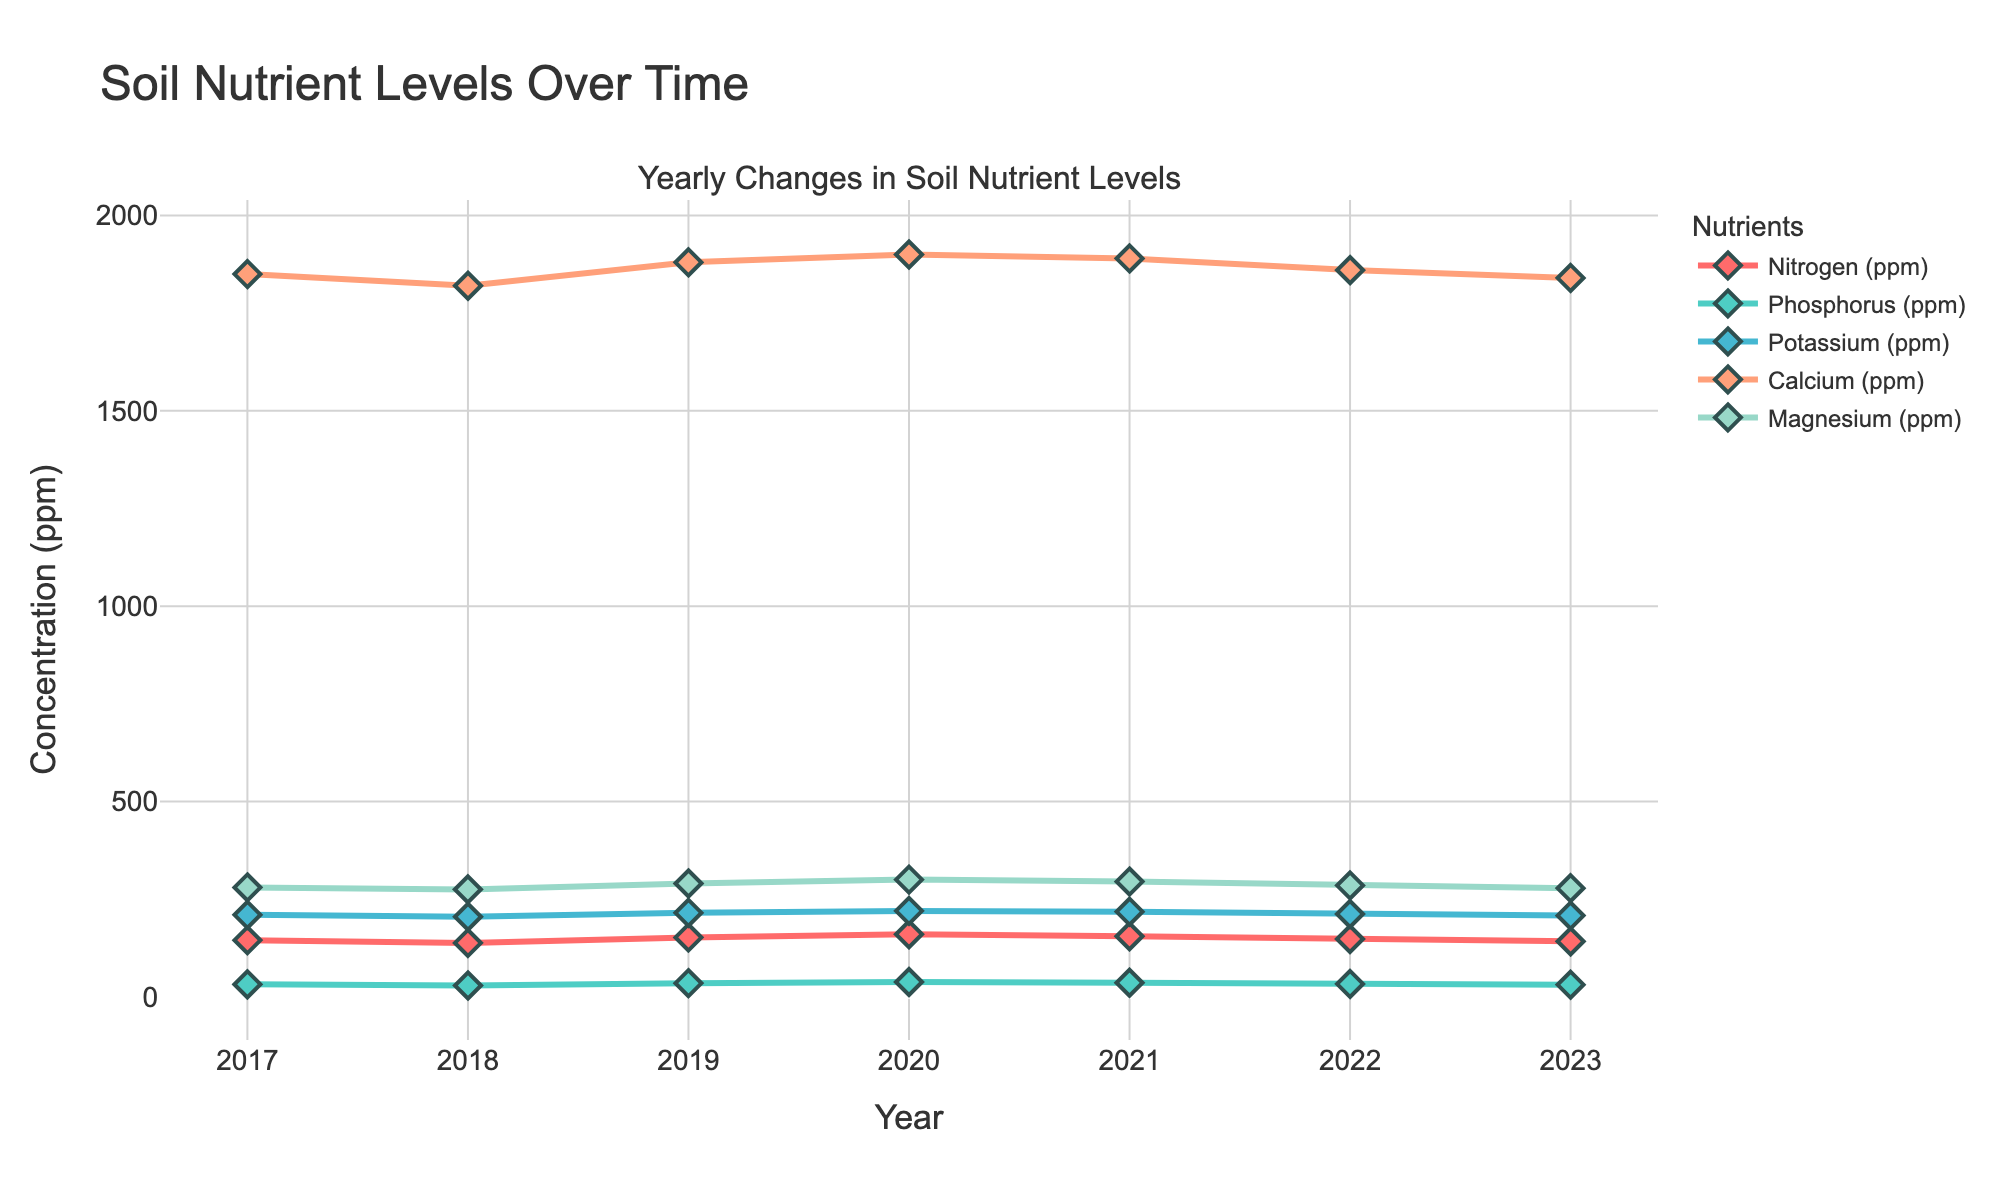What trend do we observe in the levels of Nitrogen over the 7 years? Observing the line representing Nitrogen (red line with diamonds), we can see that it starts at 145 ppm in 2017, fluctuates, peaking at 160 ppm in 2020, and decreases to 142 ppm in 2023. Overall, Nitrogen levels show slight fluctuations with an increasing trend to 2020 followed by a reduction to 2023.
Answer: Decline after initial rise Which nutrient had the highest concentration in 2020? By examining the plot, the highest peak in 2020 is found in the line for Calcium, which is marked by the orangish line, and the value is 1900 ppm.
Answer: Calcium How did the level of Phosphorus change between 2019 and 2023? Looking at the green line representing Phosphorus, it shows that Phosphorus levels increased from 35 ppm in 2019 to a peak of 38 ppm in 2020 and then decreased back to 31 ppm by 2023.
Answer: Decrease What is the overall trend of Magnesium levels from 2017 to 2023? Examining the blue line with diamond markers for Magnesium, it starts at 280 ppm in 2017, increases to a peak of 300 ppm in 2020, and then decreases to 278 ppm by 2023. It shows an overall rising trend from 2017 to 2020, followed by a decreasing trend till 2023.
Answer: Rise and then decline Between which years did Potassium show the highest increase? Observing the light blue line representing Potassium, there is a noticeable increase from 210 ppm in 2017 to 220 ppm in 2020, which is the steepest rise for Potassium in the data range.
Answer: 2017 to 2020 Was there any nutrient with consistent declining levels throughout the 7 years? By checking the plots, Nitrogen had declining levels from 2020 to 2023, and similarly, Phosphorus and Potassium also declined after their peak in 2020. None showed a consistent decline throughout all seven years.
Answer: No Which year had the lowest Magnesium levels, and what were they? Observing the blue line representing Magnesium, the lowest value observed was in 2018, with a level of 275 ppm.
Answer: 2018, 275 ppm Among Nitrogen, Phosphorus, and Potassium, which one showed the largest peak value, and in which year? By analyzing the individual lines, Nitrogen peaked at 160 ppm in 2020, Phosphorus peaked at 38 ppm in 2020, and Potassium peaked at 220 ppm in 2020. Hence, Potassium had the highest peak value among them in 2020.
Answer: Potassium, 2020 From the plot, which nutrient experienced the sharpest decline between any two consecutive years, and over which years? By examining changes year by year, Nitrogen showed the sharpest decline from 2020 (160 ppm) to 2023 (142 ppm), a decrease of 18 ppm.
Answer: Nitrogen, 2020-2023 